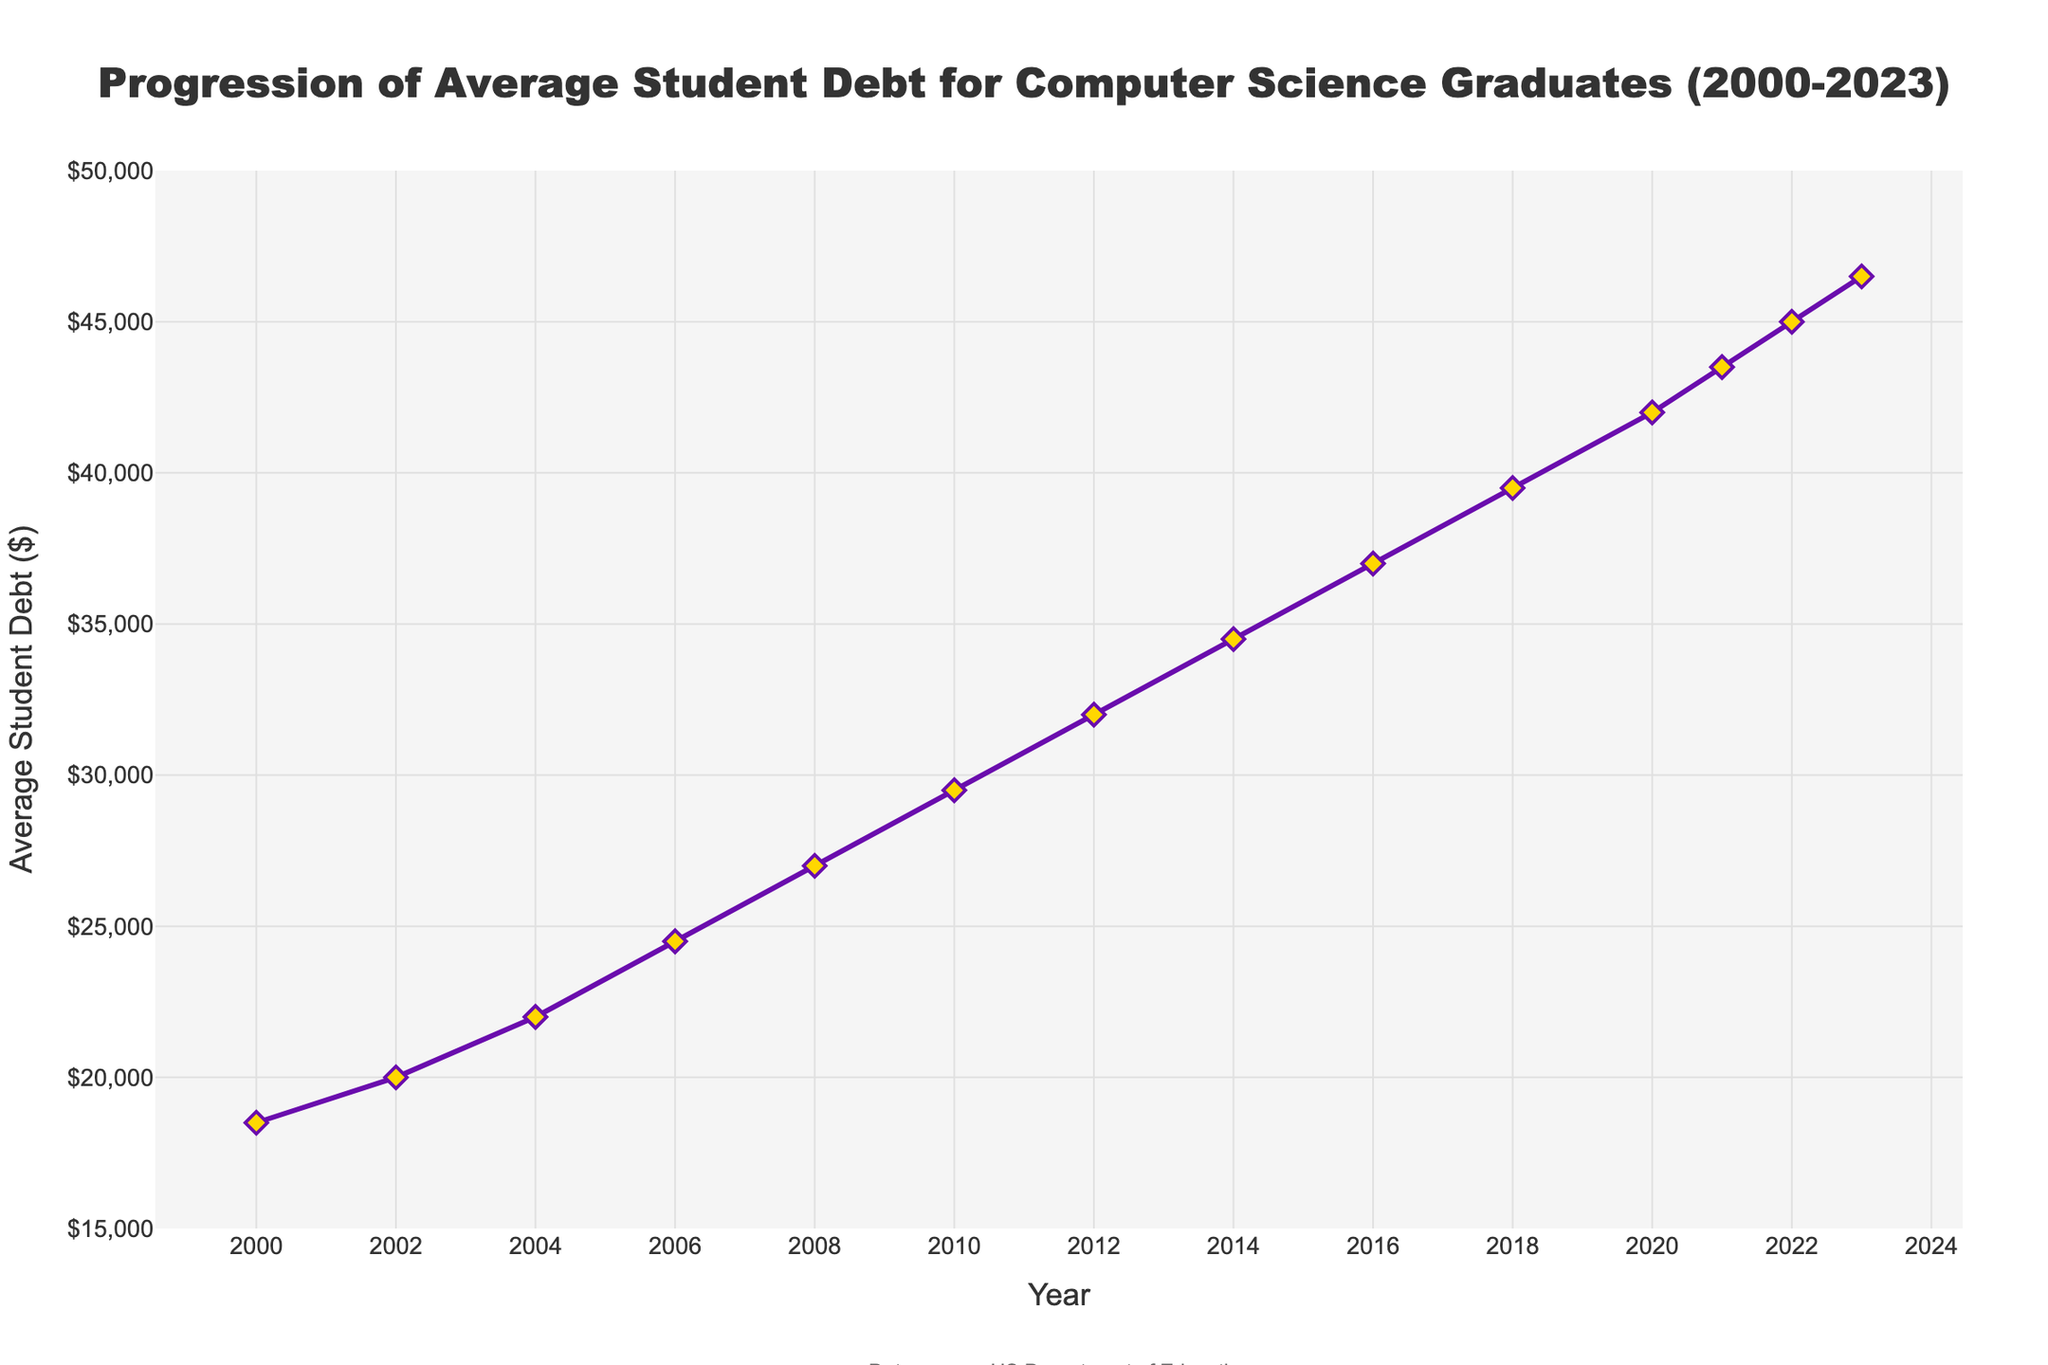What was the average student debt in 2010? According to the figure, find the point on the line that corresponds to the year 2010. Look directly upward to see the value on the y-axis.
Answer: $29,500 How much did the average student debt increase from 2004 to 2008? Locate the values for both years (2004: $22,000 and 2008: $27,000). Subtract the value of 2004 from 2008 to find the increase: $27,000 - $22,000.
Answer: $5,000 What is the difference in average student debt between 2020 and 2023? Find the average student debt for both years (2020: $42,000 and 2023: $46,500). Subtract 2020's value from 2023's value: $46,500 - $42,000.
Answer: $4,500 Which year saw the highest average student debt? Scan the values of each year on the figure and identify the year with the maximum value.
Answer: 2023 Compare the average student debt in 2006 and 2016; which year had a higher debt and by how much? Check the values for both years (2006: $24,500 and 2016: $37,000). Determine the higher value and subtract 2006 from 2016: $37,000 - $24,500.
Answer: 2016, by $12,500 What is the total increase in average student debt from 2000 to 2023? Locate the values for both years (2000: $18,500 and 2023: $46,500). Subtract 2000's value from 2023's value: $46,500 - $18,500.
Answer: $28,000 What is the average yearly increase in student debt from 2000 to 2023? Find the total increase: $46,500 - $18,500 = $28,000. The number of years between 2000 and 2023 is 23 years. Divide the total increase by the number of years: $28,000 / 23.
Answer: ~$1,217.39 Did the average student debt ever decrease between 2000 and 2023? Check if the line in the figure ever goes downward from one year to the next. There should be no downward trend indicating a decrease in debt.
Answer: No Which two consecutive years had the smallest increase in average student debt? Check the line plot for consecutive years and identify the pair with the smallest vertical increase. The smallest increase appears between 2021 and 2022.
Answer: 2021 and 2022 By what percentage did the average student debt increase from 2000 to 2023? Calculate the percentage increase from 2000 to 2023. Use the formula: ((New Value - Old Value) / Old Value) * 100. Plug in the values: (($46,500 - $18,500) / $18,500) * 100.
Answer: ~151.35% 